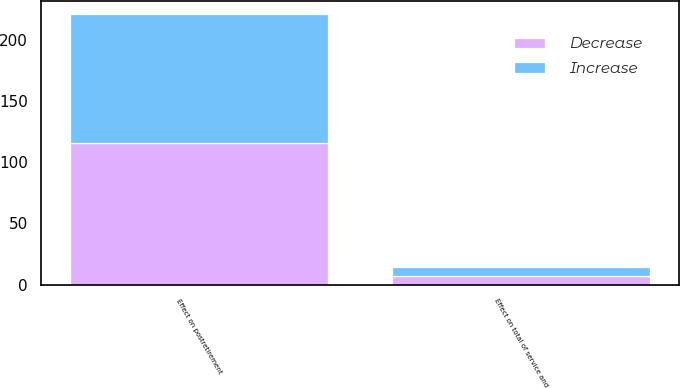Convert chart. <chart><loc_0><loc_0><loc_500><loc_500><stacked_bar_chart><ecel><fcel>Effect on total of service and<fcel>Effect on postretirement<nl><fcel>Decrease<fcel>7<fcel>116<nl><fcel>Increase<fcel>7<fcel>105<nl></chart> 